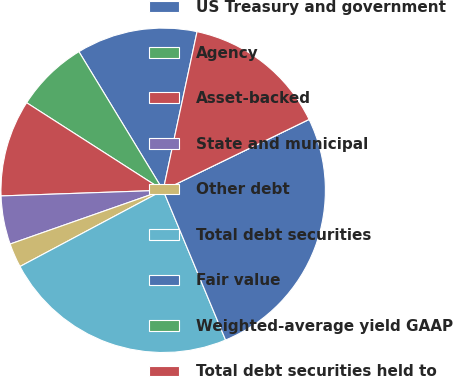<chart> <loc_0><loc_0><loc_500><loc_500><pie_chart><fcel>US Treasury and government<fcel>Agency<fcel>Asset-backed<fcel>State and municipal<fcel>Other debt<fcel>Total debt securities<fcel>Fair value<fcel>Weighted-average yield GAAP<fcel>Total debt securities held to<nl><fcel>12.04%<fcel>7.23%<fcel>9.63%<fcel>4.82%<fcel>2.41%<fcel>23.5%<fcel>25.91%<fcel>0.0%<fcel>14.45%<nl></chart> 